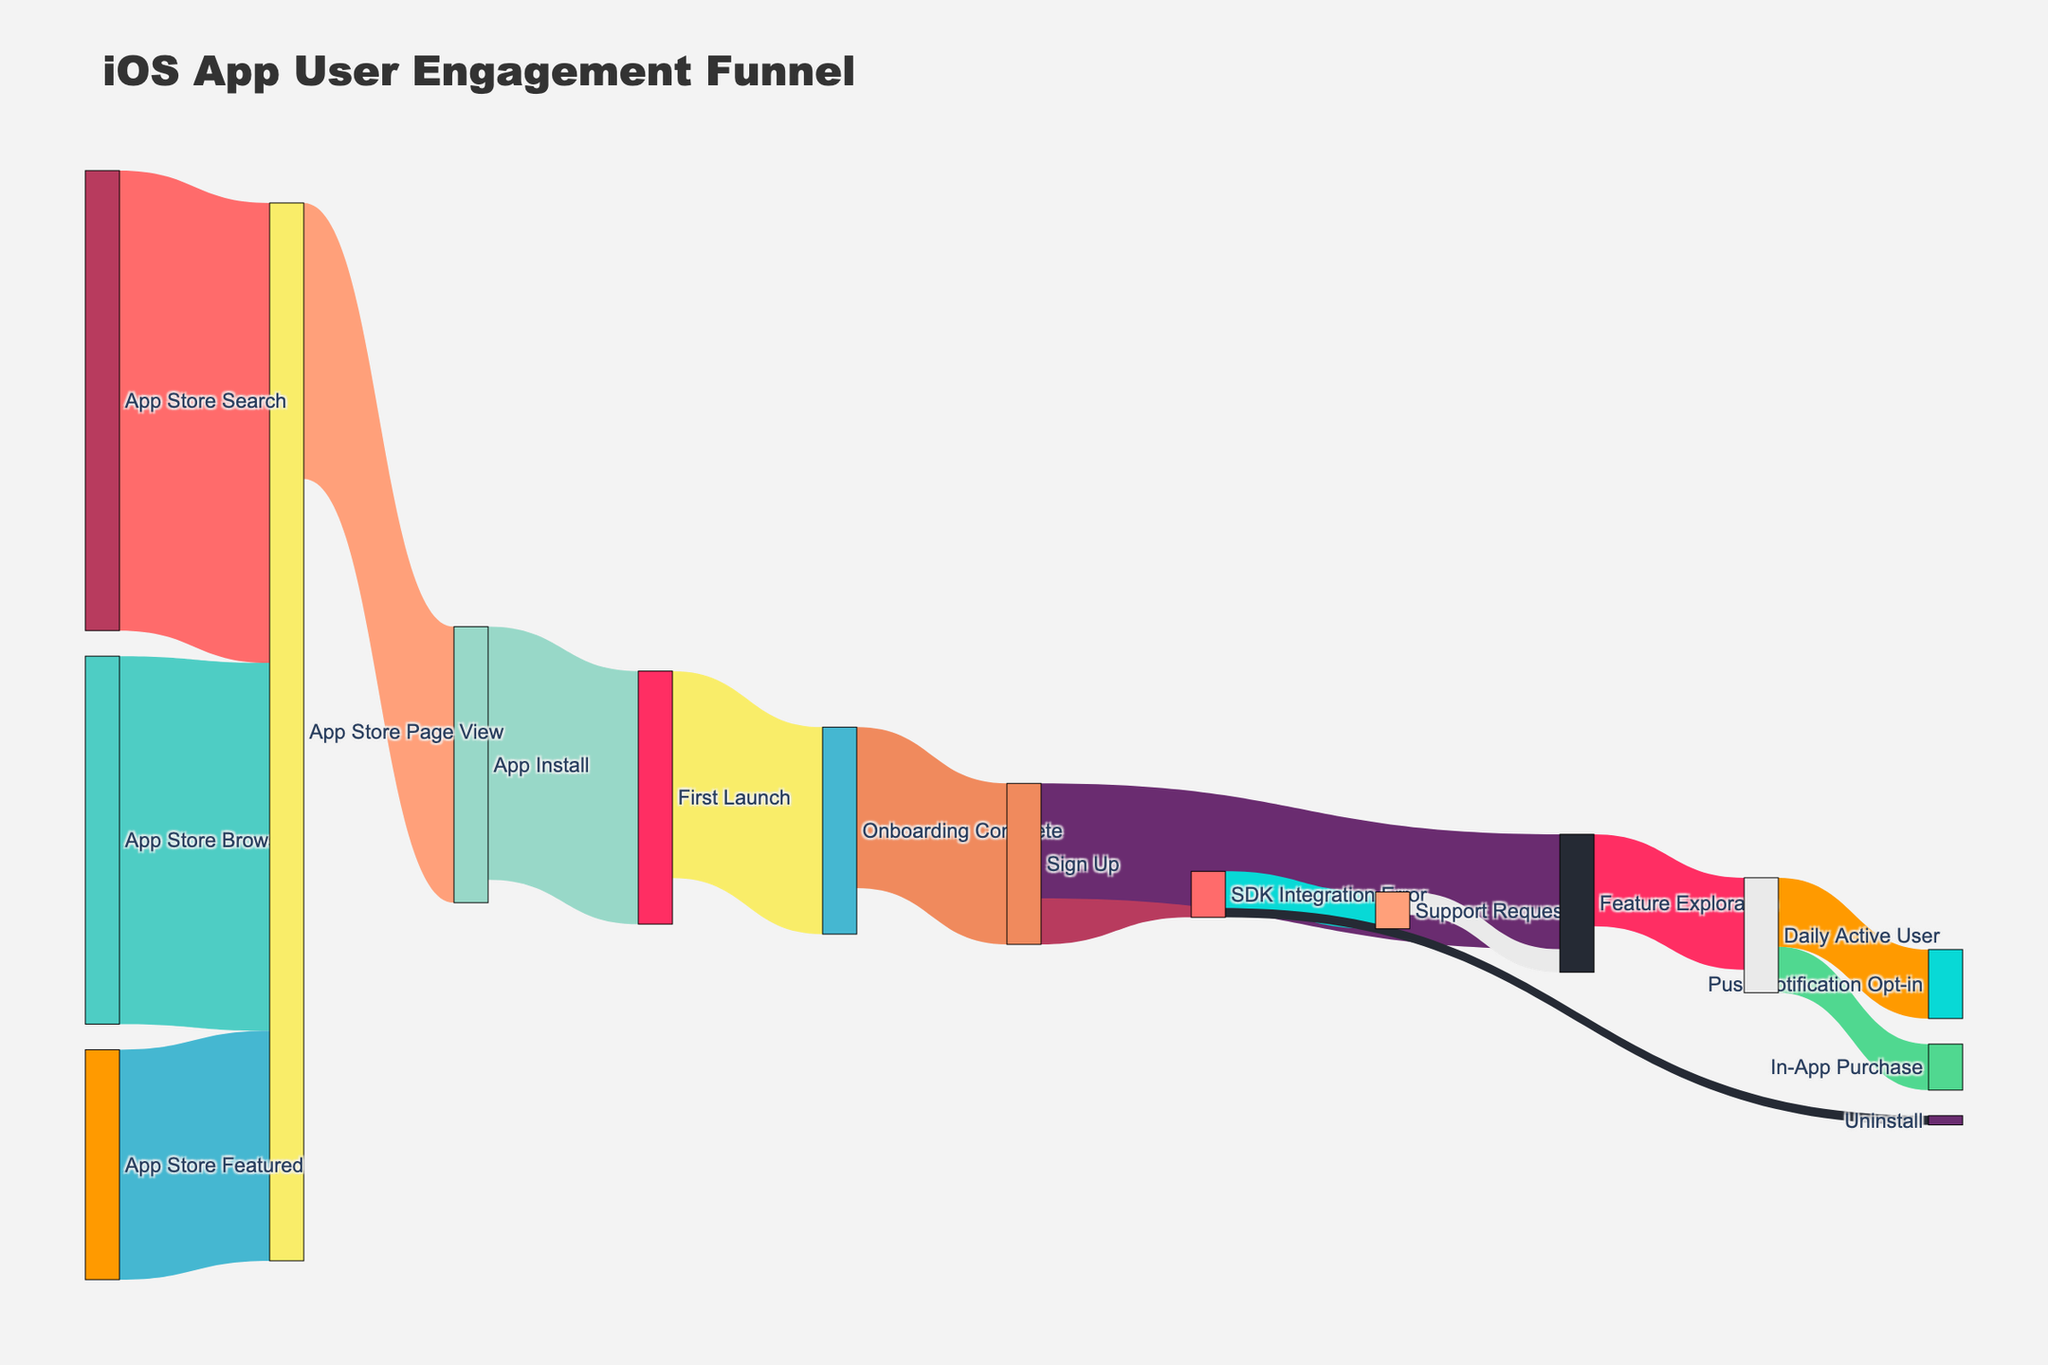How many users discovered the app through App Store Search? Locate the flow labeled "App Store Search" leading to "App Store Page View" and note the value given.
Answer: 1000 What is the total number of users who reached the App Store Page View from all sources combined? Add the values for the flows leading to "App Store Page View" from "App Store Search", "App Store Browse", and "App Store Featured". (1000 + 800 + 500)
Answer: 2300 How many users completed the onboarding process after their first launch? Identify the flow from "First Launch" to "Onboarding Complete" and note the value given.
Answer: 450 Which transition has the highest number of users, from App Store Page View to App Install or from App Install to First Launch? Compare the values of the two flows: "App Store Page View" to "App Install" (600) and "App Install" to "First Launch" (550).
Answer: App Store Page View to App Install What is the percentage of users who signed up after completing the onboarding process? Divide the number of users who signed up (350) by the number of users who completed onboarding (450) and multiply by 100 to get the percentage. (350 / 450) * 100
Answer: ~77.78% What proportion of users faced an SDK integration error after signing up? Divide the number of users who faced an SDK integration error (100) by the total number of users who signed up (350) and multiply by 100 to get the percentage. (100 / 350) * 100
Answer: ~28.57% How many users explored app features after signing up? Note the value of the flow from "Sign Up" to "Feature Exploration".
Answer: 250 Which segment leads more users to Daily Active User, Feature Exploration or Support Request? Compare the numbers: "Feature Exploration" to "Daily Active User" (200) and "Support Request" to "Feature Exploration" (50 leads into Feature Exploration, but does not go directly to Daily Active User).
Answer: Feature Exploration How many users opted in for push notifications after becoming daily active users? Identify the flow from "Daily Active User" to "Push Notification Opt-in" and note the value given.
Answer: 150 What fraction of users who made an in-app purchase after becoming daily active users opted in for push notifications? Divide the value of users who made an in-app purchase (100) by the value of users who opted in for push notifications (150).
Answer: 100/150 or 2/3 